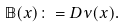<formula> <loc_0><loc_0><loc_500><loc_500>\mathbb { B } ( x ) \colon = D \nu ( x ) .</formula> 